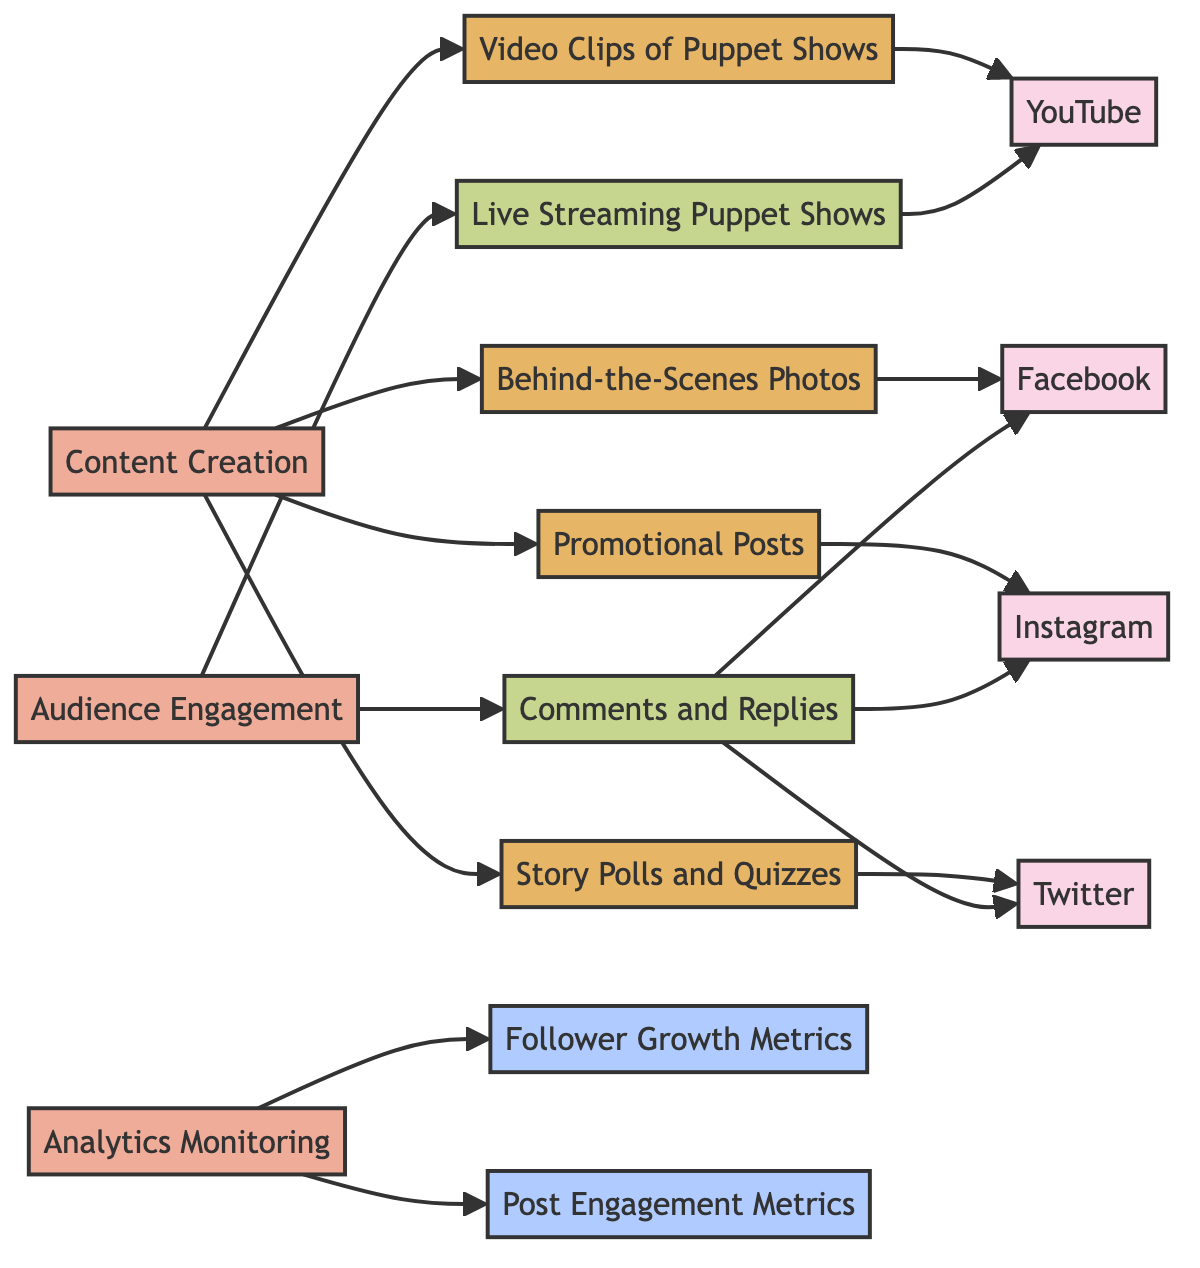What platforms are connected to video clips of puppet shows? The “Video Clips of Puppet Shows” content node has a directed edge pointing to "YouTube", indicating that it is specifically connected to that platform for sharing such content.
Answer: YouTube How many types of engagement activities are shown in the diagram? There are two engagement activities identified: "Comments and Replies" and "Live Streaming Puppet Shows". Therefore, counting these nodes gives a total of two engagement types.
Answer: 2 Which content type is connected to Facebook? The "Behind-the-Scenes Photos" content node has a directed edge pointing to "Facebook", signifying its connection to that platform for sharing such content.
Answer: Behind-the-Scenes Photos What metrics are monitored through analytics? The "Follower Growth Metrics" and "Post Engagement Metrics" are both monitoring metrics associated with analytics, making them the two tracked metrics in this diagram.
Answer: Follower Growth Metrics, Post Engagement Metrics What is the relationship between content creation and audience engagement? "Content Creation" is connected to the production of multiple types of content (Video Clips, Behind-the-Scenes Photos, Promotional Posts, Story Polls and Quizzes), while "Audience Engagement" is focused on interacting with that content, showing that the effectiveness of engagement relies on quality content.
Answer: They are both crucial for social media success How many edges are there connecting activities to content? Looking at the edges from activity nodes to content nodes, "Content Creation" has four connections, making the total number of edges from activities to content equal to four.
Answer: 4 Which activity connects to live streaming puppet shows? The "Audience Engagement" activity has a direct connection (edge) to "Live Streaming Puppet Shows", indicating that this engagement activity is involved with that particular content format.
Answer: Audience Engagement How many platforms are linked to comments and replies? "Comments and Replies" engages with three platforms: Facebook, Instagram, and Twitter, as indicated by the outgoing edges from that engagement node to these platforms.
Answer: 3 What type of content is primarily created through content creation? The type of content that is primarily created includes Video Clips of Puppet Shows, Behind-the-Scenes Photos, Promotional Posts, and Story Polls and Quizzes, indicating a focus on visual and interactive content.
Answer: Video Clips of Puppet Shows, Behind-the-Scenes Photos, Promotional Posts, Story Polls and Quizzes 